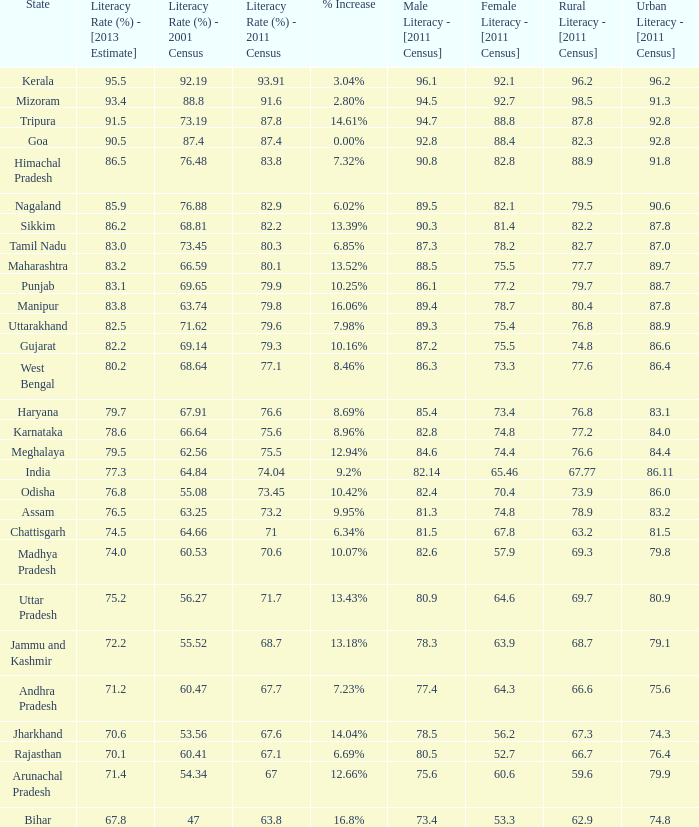What is the average estimated 2013 literacy rate for the states that had a literacy rate of 68.81% in the 2001 census and a literacy rate higher than 79.6% in the 2011 census? 86.2. Parse the table in full. {'header': ['State', 'Literacy Rate (%) - [2013 Estimate]', 'Literacy Rate (%) - 2001 Census', 'Literacy Rate (%) - 2011 Census', '% Increase', 'Male Literacy - [2011 Census]', 'Female Literacy - [2011 Census]', 'Rural Literacy - [2011 Census]', 'Urban Literacy - [2011 Census]'], 'rows': [['Kerala', '95.5', '92.19', '93.91', '3.04%', '96.1', '92.1', '96.2', '96.2'], ['Mizoram', '93.4', '88.8', '91.6', '2.80%', '94.5', '92.7', '98.5', '91.3'], ['Tripura', '91.5', '73.19', '87.8', '14.61%', '94.7', '88.8', '87.8', '92.8'], ['Goa', '90.5', '87.4', '87.4', '0.00%', '92.8', '88.4', '82.3', '92.8'], ['Himachal Pradesh', '86.5', '76.48', '83.8', '7.32%', '90.8', '82.8', '88.9', '91.8'], ['Nagaland', '85.9', '76.88', '82.9', '6.02%', '89.5', '82.1', '79.5', '90.6'], ['Sikkim', '86.2', '68.81', '82.2', '13.39%', '90.3', '81.4', '82.2', '87.8'], ['Tamil Nadu', '83.0', '73.45', '80.3', '6.85%', '87.3', '78.2', '82.7', '87.0'], ['Maharashtra', '83.2', '66.59', '80.1', '13.52%', '88.5', '75.5', '77.7', '89.7'], ['Punjab', '83.1', '69.65', '79.9', '10.25%', '86.1', '77.2', '79.7', '88.7'], ['Manipur', '83.8', '63.74', '79.8', '16.06%', '89.4', '78.7', '80.4', '87.8'], ['Uttarakhand', '82.5', '71.62', '79.6', '7.98%', '89.3', '75.4', '76.8', '88.9'], ['Gujarat', '82.2', '69.14', '79.3', '10.16%', '87.2', '75.5', '74.8', '86.6'], ['West Bengal', '80.2', '68.64', '77.1', '8.46%', '86.3', '73.3', '77.6', '86.4'], ['Haryana', '79.7', '67.91', '76.6', '8.69%', '85.4', '73.4', '76.8', '83.1'], ['Karnataka', '78.6', '66.64', '75.6', '8.96%', '82.8', '74.8', '77.2', '84.0'], ['Meghalaya', '79.5', '62.56', '75.5', '12.94%', '84.6', '74.4', '76.6', '84.4'], ['India', '77.3', '64.84', '74.04', '9.2%', '82.14', '65.46', '67.77', '86.11'], ['Odisha', '76.8', '55.08', '73.45', '10.42%', '82.4', '70.4', '73.9', '86.0'], ['Assam', '76.5', '63.25', '73.2', '9.95%', '81.3', '74.8', '78.9', '83.2'], ['Chattisgarh', '74.5', '64.66', '71', '6.34%', '81.5', '67.8', '63.2', '81.5'], ['Madhya Pradesh', '74.0', '60.53', '70.6', '10.07%', '82.6', '57.9', '69.3', '79.8'], ['Uttar Pradesh', '75.2', '56.27', '71.7', '13.43%', '80.9', '64.6', '69.7', '80.9'], ['Jammu and Kashmir', '72.2', '55.52', '68.7', '13.18%', '78.3', '63.9', '68.7', '79.1'], ['Andhra Pradesh', '71.2', '60.47', '67.7', '7.23%', '77.4', '64.3', '66.6', '75.6'], ['Jharkhand', '70.6', '53.56', '67.6', '14.04%', '78.5', '56.2', '67.3', '74.3'], ['Rajasthan', '70.1', '60.41', '67.1', '6.69%', '80.5', '52.7', '66.7', '76.4'], ['Arunachal Pradesh', '71.4', '54.34', '67', '12.66%', '75.6', '60.6', '59.6', '79.9'], ['Bihar', '67.8', '47', '63.8', '16.8%', '73.4', '53.3', '62.9', '74.8']]} 